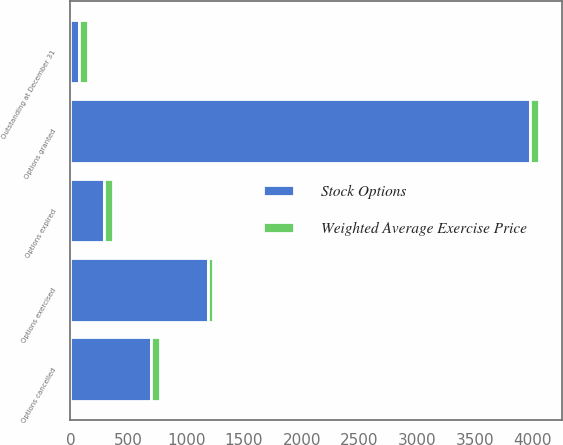Convert chart. <chart><loc_0><loc_0><loc_500><loc_500><stacked_bar_chart><ecel><fcel>Outstanding at December 31<fcel>Options granted<fcel>Options exercised<fcel>Options cancelled<fcel>Options expired<nl><fcel>Stock Options<fcel>77.87<fcel>3975<fcel>1190<fcel>698<fcel>294<nl><fcel>Weighted Average Exercise Price<fcel>71.25<fcel>76.45<fcel>43.68<fcel>77.87<fcel>76.85<nl></chart> 